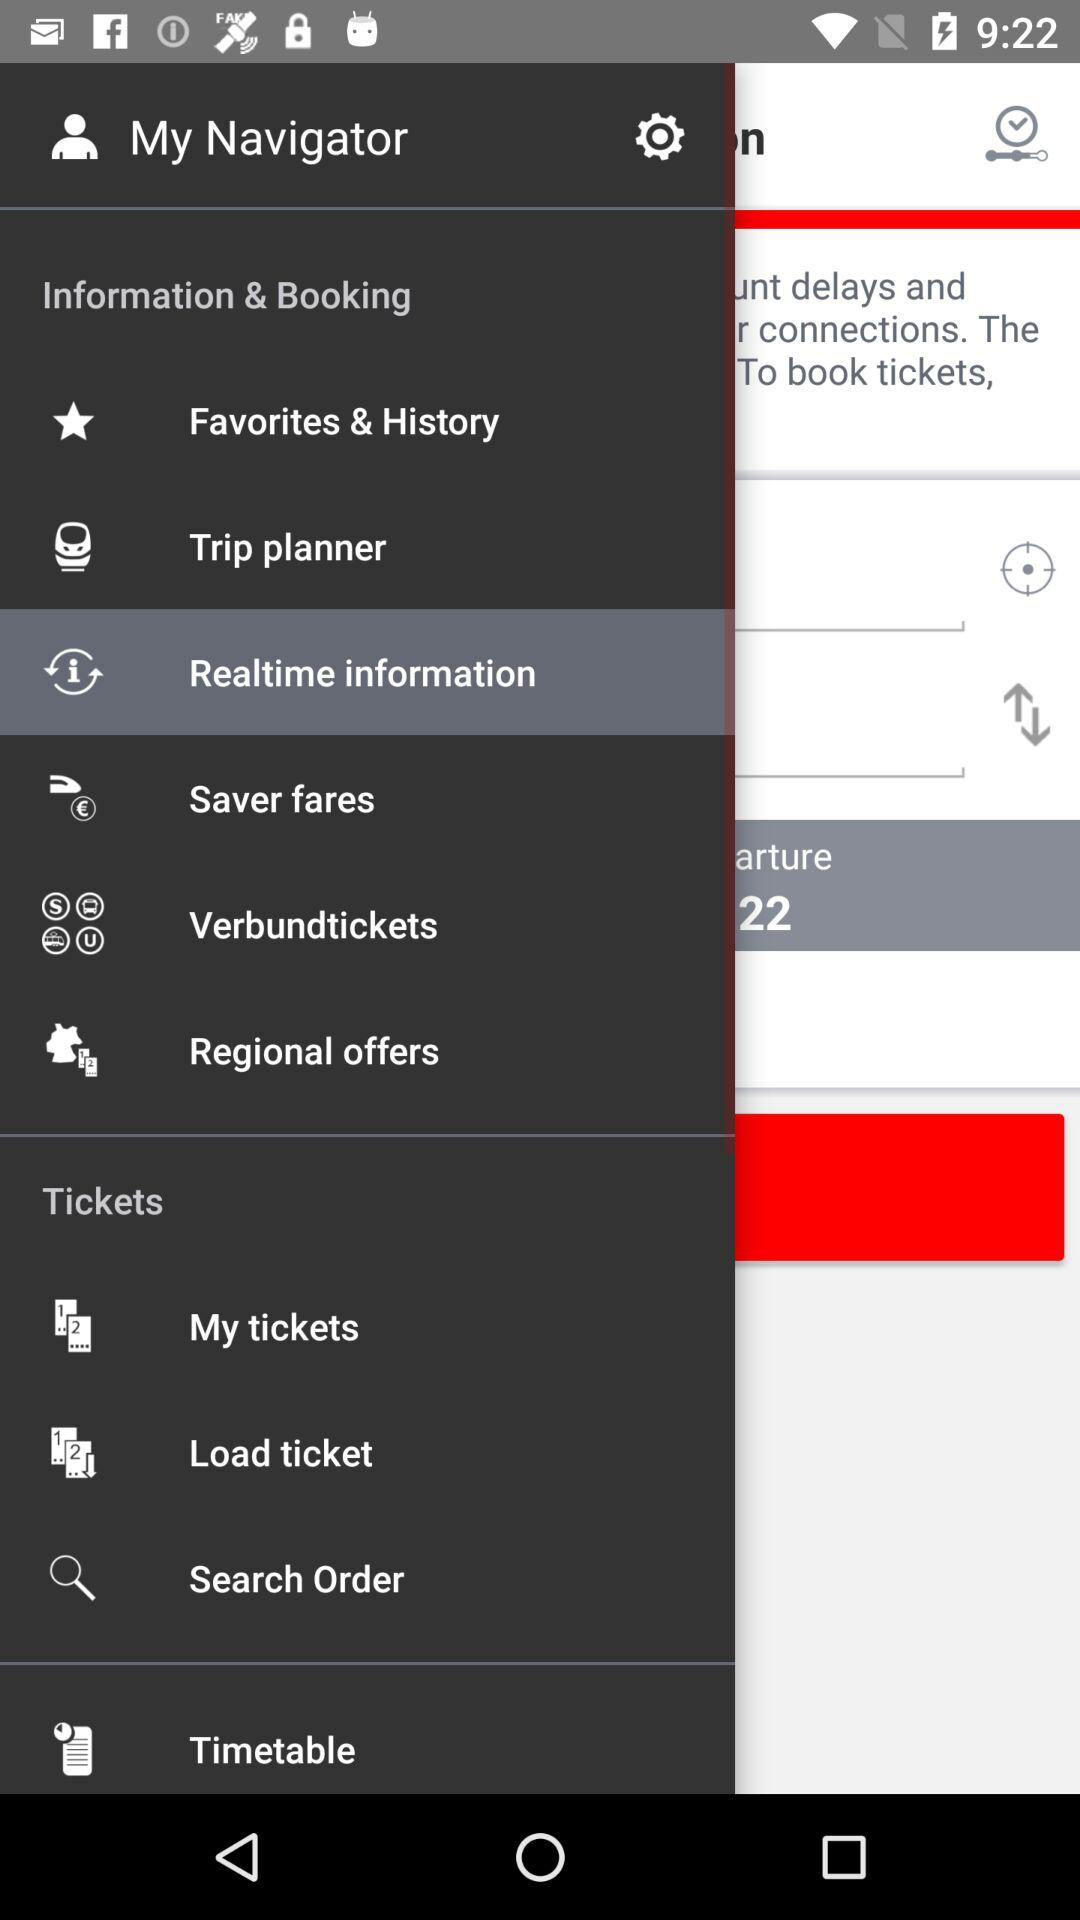Which is the selected option in Information and Booking? The selected option is "Realtime information". 